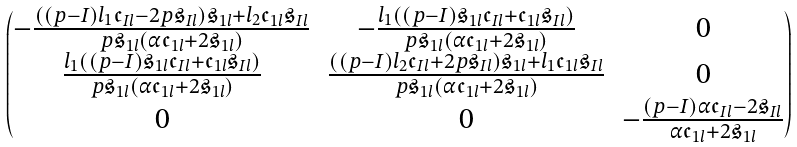<formula> <loc_0><loc_0><loc_500><loc_500>\begin{pmatrix} - \frac { \left ( ( p - I ) l _ { 1 } \mathfrak { c } _ { I l } - 2 p \mathfrak { s } _ { I l } \right ) \mathfrak { s } _ { 1 l } + l _ { 2 } \mathfrak { c } _ { 1 l } \mathfrak { s } _ { I l } } { p \mathfrak { s } _ { 1 l } \left ( \alpha \mathfrak { c } _ { 1 l } + 2 \mathfrak { s } _ { 1 l } \right ) } & - \frac { l _ { 1 } \left ( ( p - I ) \mathfrak { s } _ { 1 l } \mathfrak { c } _ { I l } + \mathfrak { c } _ { 1 l } \mathfrak { s } _ { I l } \right ) } { p \mathfrak { s } _ { 1 l } \left ( \alpha \mathfrak { c } _ { 1 l } + 2 \mathfrak { s } _ { 1 l } \right ) } & 0 \\ \frac { l _ { 1 } \left ( ( p - I ) \mathfrak { s } _ { 1 l } \mathfrak { c } _ { I l } + \mathfrak { c } _ { 1 l } \mathfrak { s } _ { I l } \right ) } { p \mathfrak { s } _ { 1 l } \left ( \alpha \mathfrak { c } _ { 1 l } + 2 \mathfrak { s } _ { 1 l } \right ) } & \frac { \left ( ( p - I ) l _ { 2 } \mathfrak { c } _ { I l } + 2 p \mathfrak { s } _ { I l } \right ) \mathfrak { s } _ { 1 l } + l _ { 1 } \mathfrak { c } _ { 1 l } \mathfrak { s } _ { I l } } { p \mathfrak { s } _ { 1 l } \left ( \alpha \mathfrak { c } _ { 1 l } + 2 \mathfrak { s } _ { 1 l } \right ) } & 0 \\ 0 & 0 & - \frac { ( p - I ) \alpha \mathfrak { c } _ { I l } - 2 \mathfrak { s } _ { I l } } { \alpha \mathfrak { c } _ { 1 l } + 2 \mathfrak { s } _ { 1 l } } \end{pmatrix}</formula> 